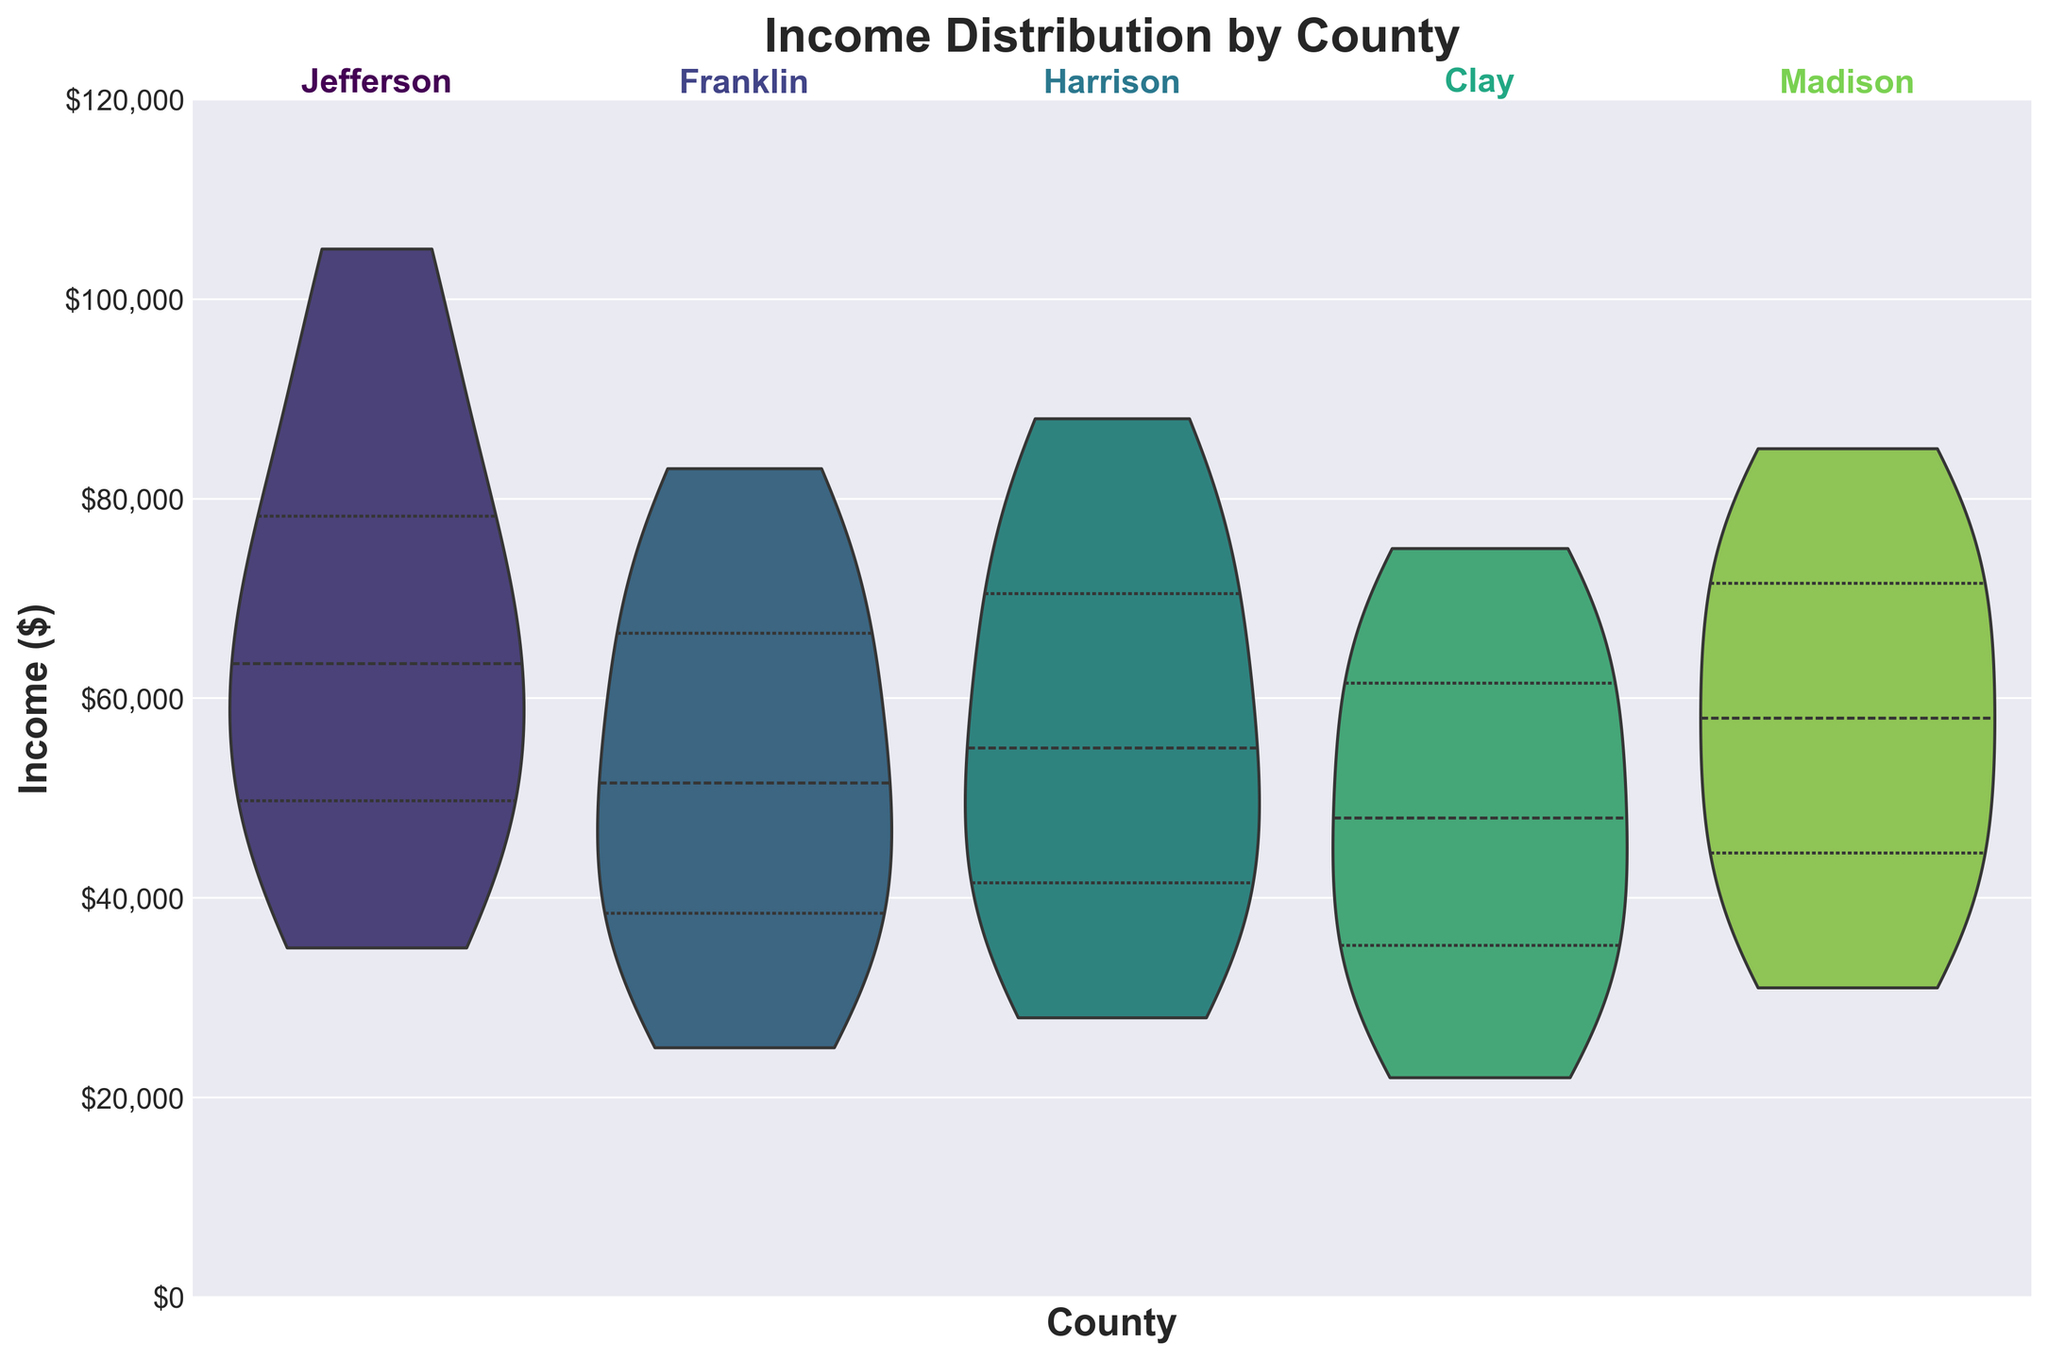What is the title of the figure? The title is usually placed at the top of the figure, and it summarizes the content of the chart. The title here is "Income Distribution by County."
Answer: Income Distribution by County Which county has the widest spread of income distribution? By observing the spread of the violin plots, the width at different income levels indicates the density of data points at that level. Jefferson appears to have the widest spread, as its plot spans a larger range along the y-axis compared to the others.
Answer: Jefferson How does the median income for Madison compare to Harrison? The median income is represented by the white dot in the violin plot for each county. By comparing the position of these dots, the median income for Madison is higher than that for Harrison.
Answer: Madison has a higher median income What is the approximate range of incomes in Franklin? The range of incomes can be observed from the lowest to the highest point of the violin plot for Franklin. It stretches from about $25,000 to roughly $83,000.
Answer: $25,000 to $83,000 How do the quartile ranges for Jefferson and Clay compare? The quartile ranges are represented by the inner lines within the violin plots. Jefferson's quartile ranges are higher than those of Clay, indicating that both the lower and upper quartiles of Jefferson are at higher income levels.
Answer: Jefferson has higher quartile ranges Which county shows the least variability in income distribution? Variability in income distribution is reflected by the density and spread of the violin plots. Clay shows the least variability, as it has a narrower and more concentrated distribution.
Answer: Clay Is there any county with an income distribution skewed towards higher income? To determine if a distribution is skewed towards higher income, we observe the shape of the violin plot. Madison seems to be skewed towards higher income as the plot is fatter at the higher end of the income range.
Answer: Madison What income levels do the majority of households in Harrison fall between? By looking at the width of the violin plot for Harrison, which indicates the density of data points, the majority of households fall between roughly $34,000 and $72,000.
Answer: $34,000 and $72,000 Based on the plot, which county has the highest maximum income observed? The highest maximum income can be identified from the topmost point of the violin plots. Jefferson has the highest observed maximum income, reaching up to $105,000.
Answer: Jefferson 